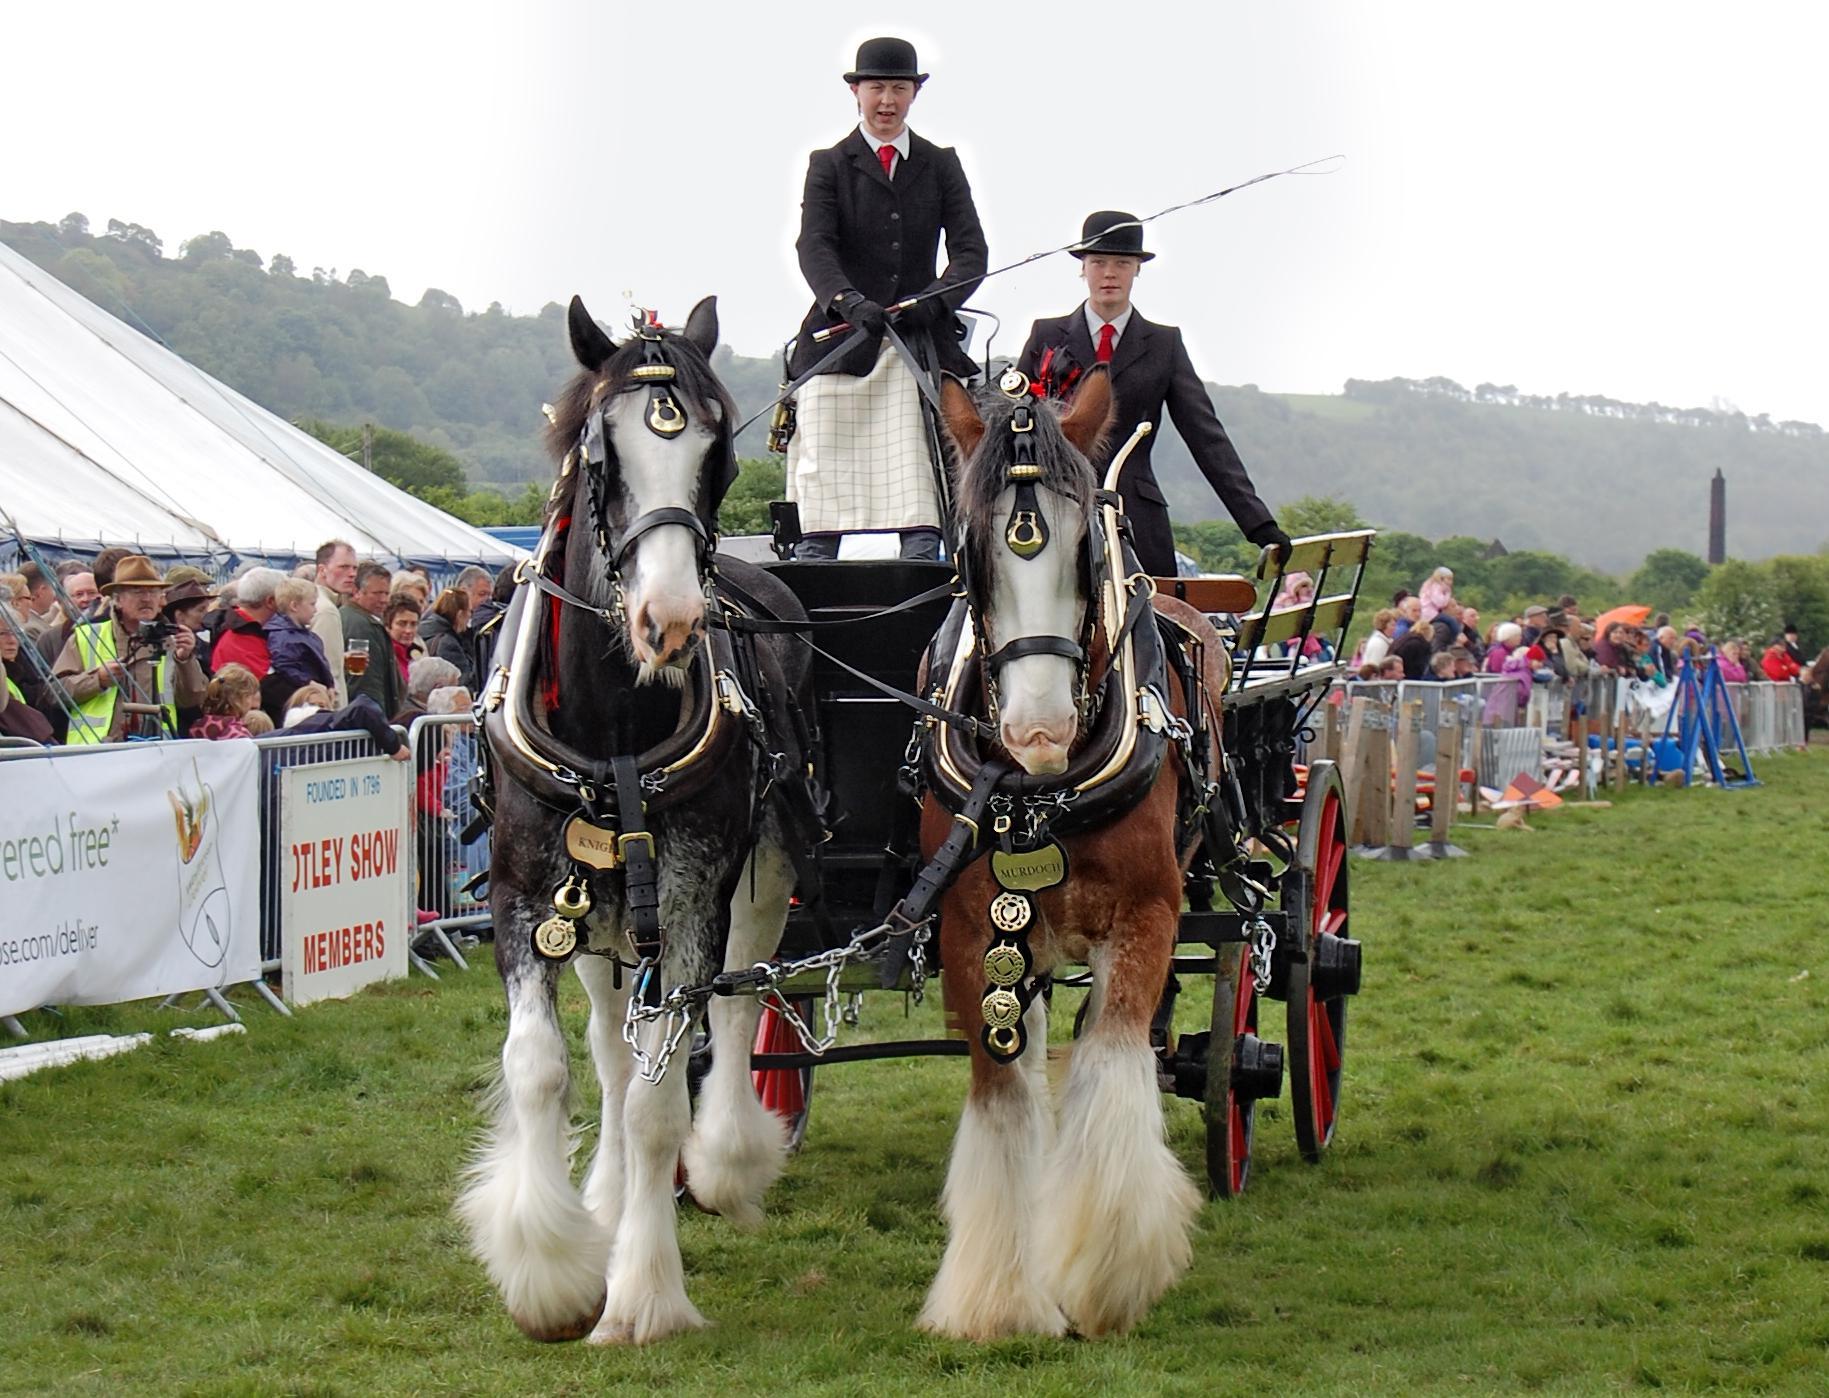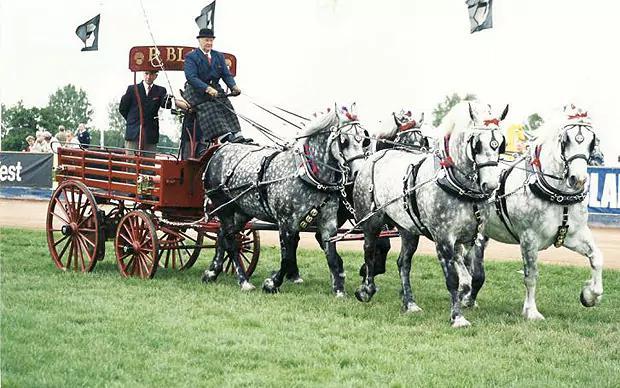The first image is the image on the left, the second image is the image on the right. Analyze the images presented: Is the assertion "An image shows a cart pulled by two Clydesdale horses only." valid? Answer yes or no. Yes. The first image is the image on the left, the second image is the image on the right. Examine the images to the left and right. Is the description "The horses in the image on the right have furry feet." accurate? Answer yes or no. No. 